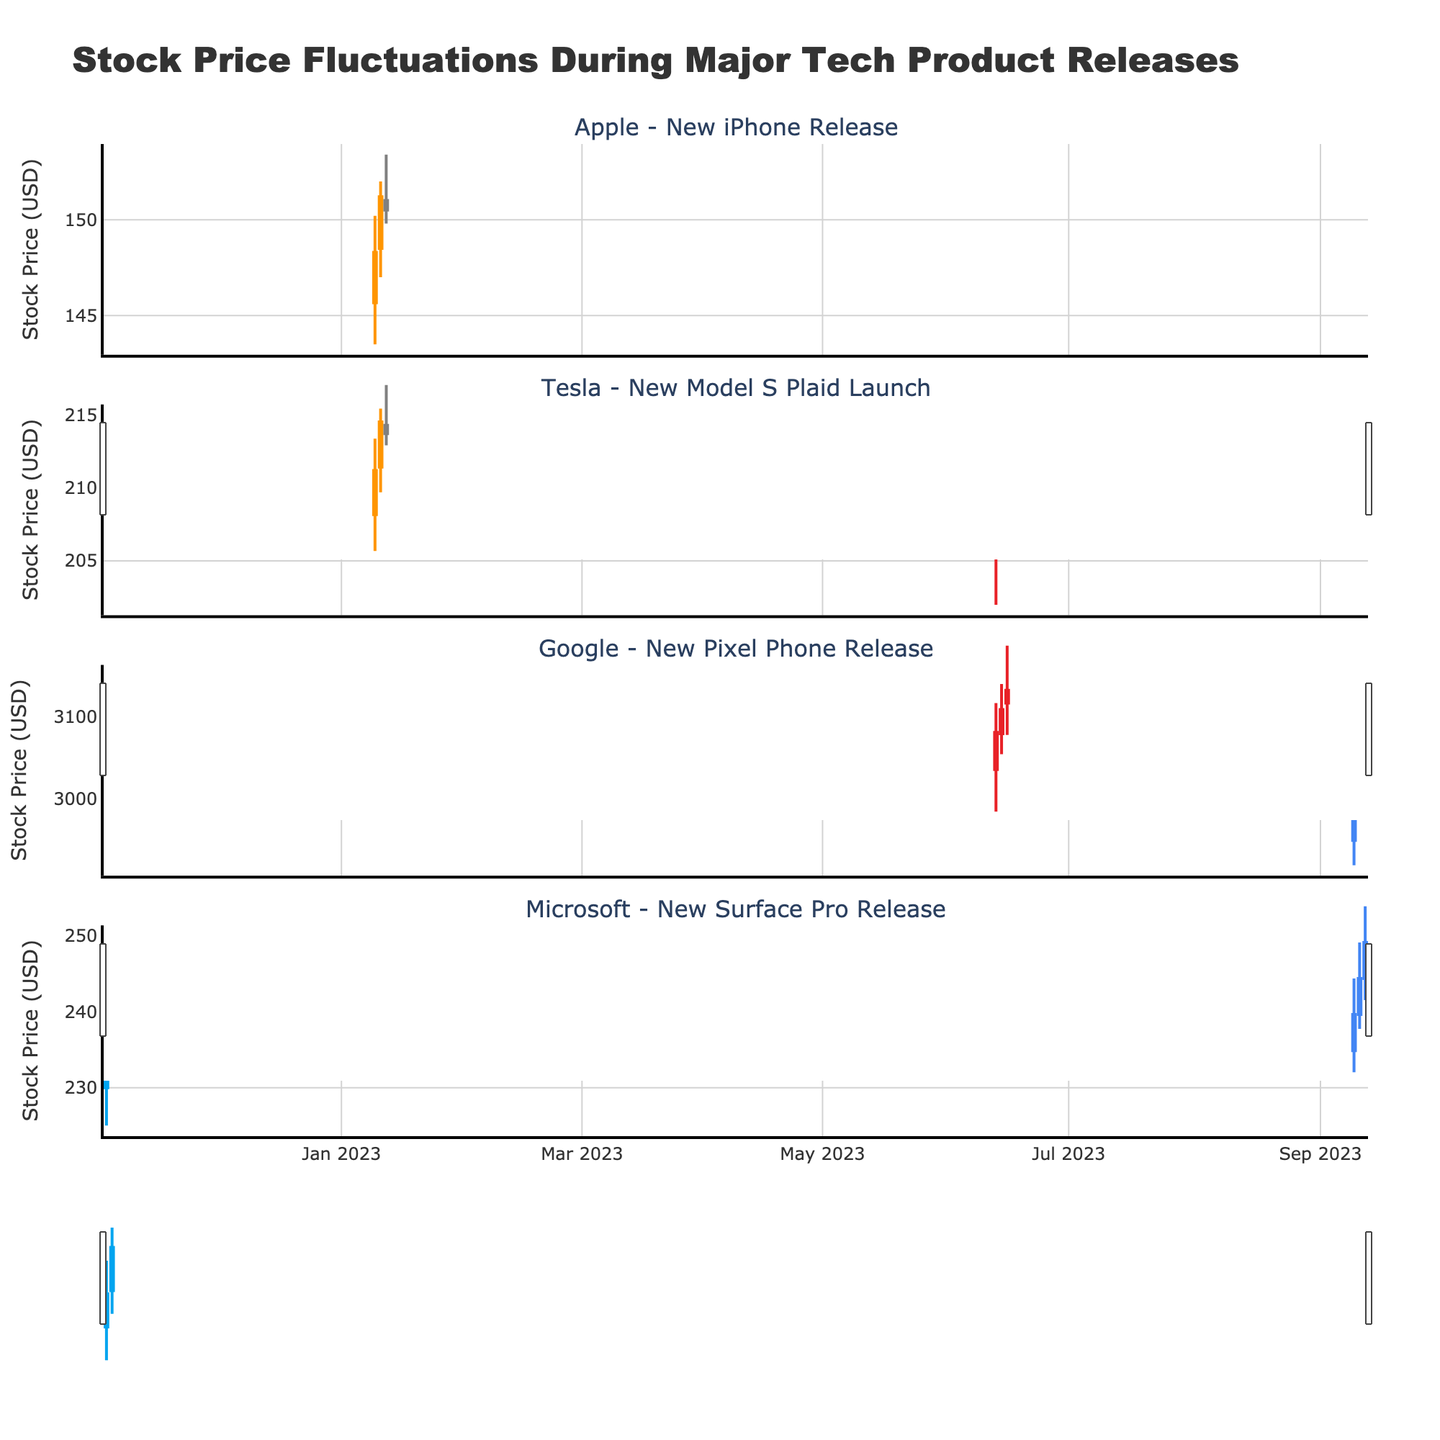Which company had the highest closing stock price during their product release? By examining the highest "Close" values in each subplot, we see that Google's closing stock price reached 3100.00, which is the highest among all companies.
Answer: Google What was the closing stock price range for Tesla's new Model S Plaid launch? To determine the range, consider the lowest and highest closing prices for Tesla during the three days: 208.20 and 211.50. The range is 211.50 - 208.20 = 3.30.
Answer: 3.30 On which date did Apple see the highest stock price during the new iPhone release event, and what was that price? Check the "High" prices for Apple in the subplot. On January 11th, 2023, the highest price was 152.00.
Answer: January 11th, 2023, 152.00 During the new Surface Pro release by Microsoft, was there an increase or decrease in stock price from November 3rd to November 5th, and by how much? Compare the "Close" price on November 3rd (235.00) with November 5th (245.00). There is an increase of 245.00 - 235.00 = 10.00.
Answer: Increase, 10.00 Which company experienced the most stable stock price during their product release event, based on the difference between the highest and lowest closing prices? Compare the closing price ranges for each company:
- Apple: 151.20 - 148.30 = 2.90
- Tesla: 211.50 - 208.20 = 3.30
- Google: 3100.00 - 3000.00 = 100.00
- Microsoft: 245.00 - 235.00 = 10.00
The smallest range is for Apple.
Answer: Apple How did the stock price of Google change over the three days of the new Pixel Phone release? Look at the "Close" prices for Google over the three days:
- On September 12: 3000.00
- On September 13: 3050.00
- On September 14: 3100.00
It shows an increase each day.
Answer: Increased What is the lowest price Tesla's stock hit during the new Model S Plaid launch event? Find the minimum "Low" value for Tesla during the event. The lowest price is 202.00 on June 14th, 2023.
Answer: 202.00 Which day during Microsoft's new Surface Pro release event had the highest trading range (difference between High and Low prices)? Calculate the differences for each day:
- November 3: 240.00 - 225.00 = 15.00
- November 4: 245.00 - 232.00 = 13.00
- November 5: 250.00 - 238.00 = 12.00
The highest range is on November 3.
Answer: November 3 Summarize the movement in Apple's stock prices during the new iPhone release event. On January 10, the stock opened at 145.67 and closed at 148.30. On January 11, it opened at 148.50 and closed at 151.20. On January 12, it opened at 151.00 and closed at 150.50. Overall, there was an upward movement initially followed by a slight decline on the last day.
Answer: Initial increase then slight decline 